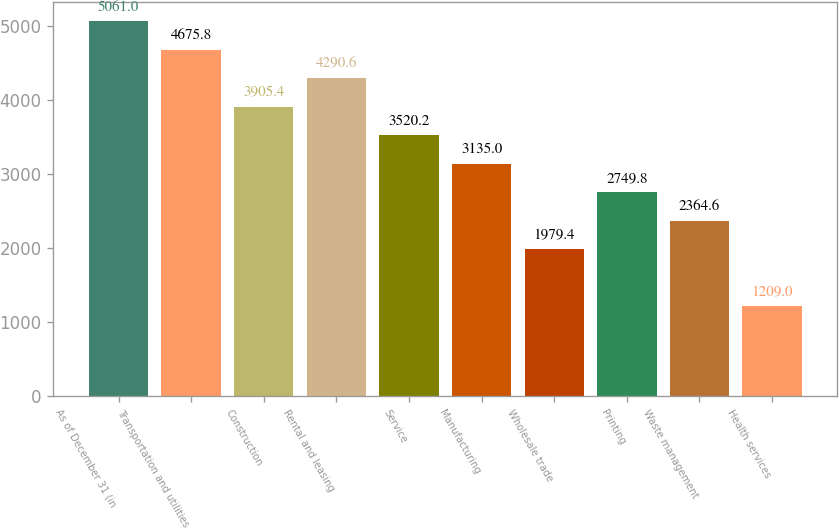Convert chart. <chart><loc_0><loc_0><loc_500><loc_500><bar_chart><fcel>As of December 31 (in<fcel>Transportation and utilities<fcel>Construction<fcel>Rental and leasing<fcel>Service<fcel>Manufacturing<fcel>Wholesale trade<fcel>Printing<fcel>Waste management<fcel>Health services<nl><fcel>5061<fcel>4675.8<fcel>3905.4<fcel>4290.6<fcel>3520.2<fcel>3135<fcel>1979.4<fcel>2749.8<fcel>2364.6<fcel>1209<nl></chart> 